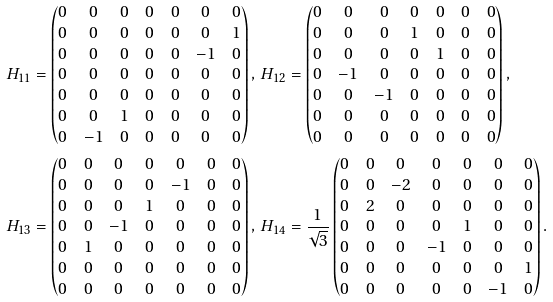Convert formula to latex. <formula><loc_0><loc_0><loc_500><loc_500>& H _ { 1 1 } = \left ( \begin{matrix} 0 & 0 & 0 & 0 & 0 & 0 & 0 \\ 0 & 0 & 0 & 0 & 0 & 0 & 1 \\ 0 & 0 & 0 & 0 & 0 & - 1 & 0 \\ 0 & 0 & 0 & 0 & 0 & 0 & 0 \\ 0 & 0 & 0 & 0 & 0 & 0 & 0 \\ 0 & 0 & 1 & 0 & 0 & 0 & 0 \\ 0 & - 1 & 0 & 0 & 0 & 0 & 0 \end{matrix} \right ) , \, H _ { 1 2 } = \left ( \begin{matrix} 0 & 0 & 0 & 0 & 0 & 0 & 0 \\ 0 & 0 & 0 & 1 & 0 & 0 & 0 \\ 0 & 0 & 0 & 0 & 1 & 0 & 0 \\ 0 & - 1 & 0 & 0 & 0 & 0 & 0 \\ 0 & 0 & - 1 & 0 & 0 & 0 & 0 \\ 0 & 0 & 0 & 0 & 0 & 0 & 0 \\ 0 & 0 & 0 & 0 & 0 & 0 & 0 \end{matrix} \right ) , \\ & H _ { 1 3 } = \left ( \begin{matrix} 0 & 0 & 0 & 0 & 0 & 0 & 0 \\ 0 & 0 & 0 & 0 & - 1 & 0 & 0 \\ 0 & 0 & 0 & 1 & 0 & 0 & 0 \\ 0 & 0 & - 1 & 0 & 0 & 0 & 0 \\ 0 & 1 & 0 & 0 & 0 & 0 & 0 \\ 0 & 0 & 0 & 0 & 0 & 0 & 0 \\ 0 & 0 & 0 & 0 & 0 & 0 & 0 \end{matrix} \right ) , \, H _ { 1 4 } = \frac { 1 } { \sqrt { 3 } } \left ( \begin{matrix} 0 & 0 & 0 & 0 & 0 & 0 & 0 \\ 0 & 0 & - 2 & 0 & 0 & 0 & 0 \\ 0 & 2 & 0 & 0 & 0 & 0 & 0 \\ 0 & 0 & 0 & 0 & 1 & 0 & 0 \\ 0 & 0 & 0 & - 1 & 0 & 0 & 0 \\ 0 & 0 & 0 & 0 & 0 & 0 & 1 \\ 0 & 0 & 0 & 0 & 0 & - 1 & 0 \end{matrix} \right ) .</formula> 